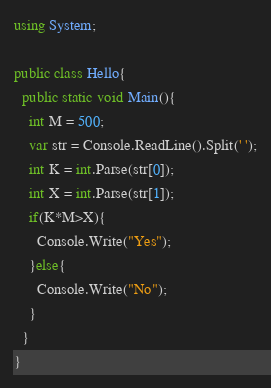<code> <loc_0><loc_0><loc_500><loc_500><_C#_>using System;

public class Hello{
  public static void Main(){
    int M = 500;
    var str = Console.ReadLine().Split(' ');
    int K = int.Parse(str[0]);
    int X = int.Parse(str[1]);
    if(K*M>X){
      Console.Write("Yes");
    }else{
      Console.Write("No");
    }
  }
}</code> 